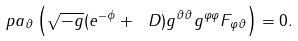Convert formula to latex. <formula><loc_0><loc_0><loc_500><loc_500>\ p a _ { \vartheta } \left ( \sqrt { - g } ( e ^ { - \phi } + \ D ) g ^ { \vartheta \vartheta } g ^ { \varphi \varphi } F _ { \varphi \vartheta } \right ) = 0 .</formula> 